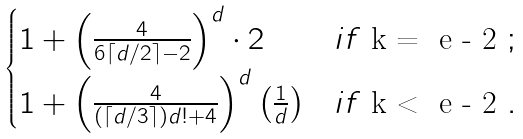Convert formula to latex. <formula><loc_0><loc_0><loc_500><loc_500>\begin{cases} 1 + \left ( \frac { 4 } { 6 \lceil d / 2 \rceil - 2 } \right ) ^ { d } \cdot 2 & i f $ k = \ e - 2 $ ; \\ 1 + \left ( \frac { 4 } { ( \lceil d / 3 \rceil ) d ! + 4 } \right ) ^ { d } \left ( \frac { 1 } { d } \right ) & i f $ k < \ e - 2 $ . \end{cases}</formula> 